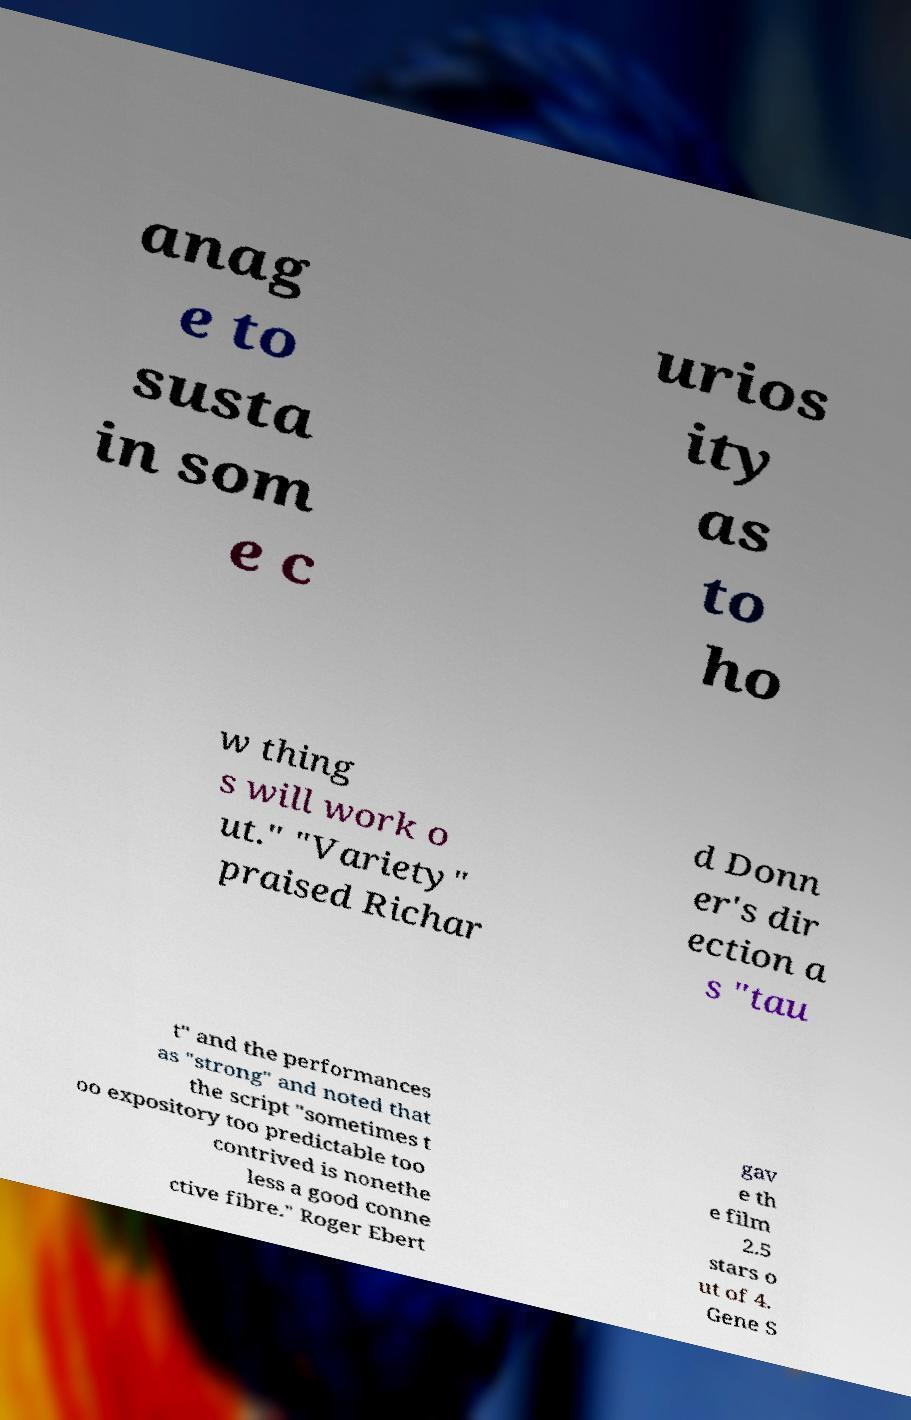Please read and relay the text visible in this image. What does it say? anag e to susta in som e c urios ity as to ho w thing s will work o ut." "Variety" praised Richar d Donn er's dir ection a s "tau t" and the performances as "strong" and noted that the script "sometimes t oo expository too predictable too contrived is nonethe less a good conne ctive fibre." Roger Ebert gav e th e film 2.5 stars o ut of 4. Gene S 